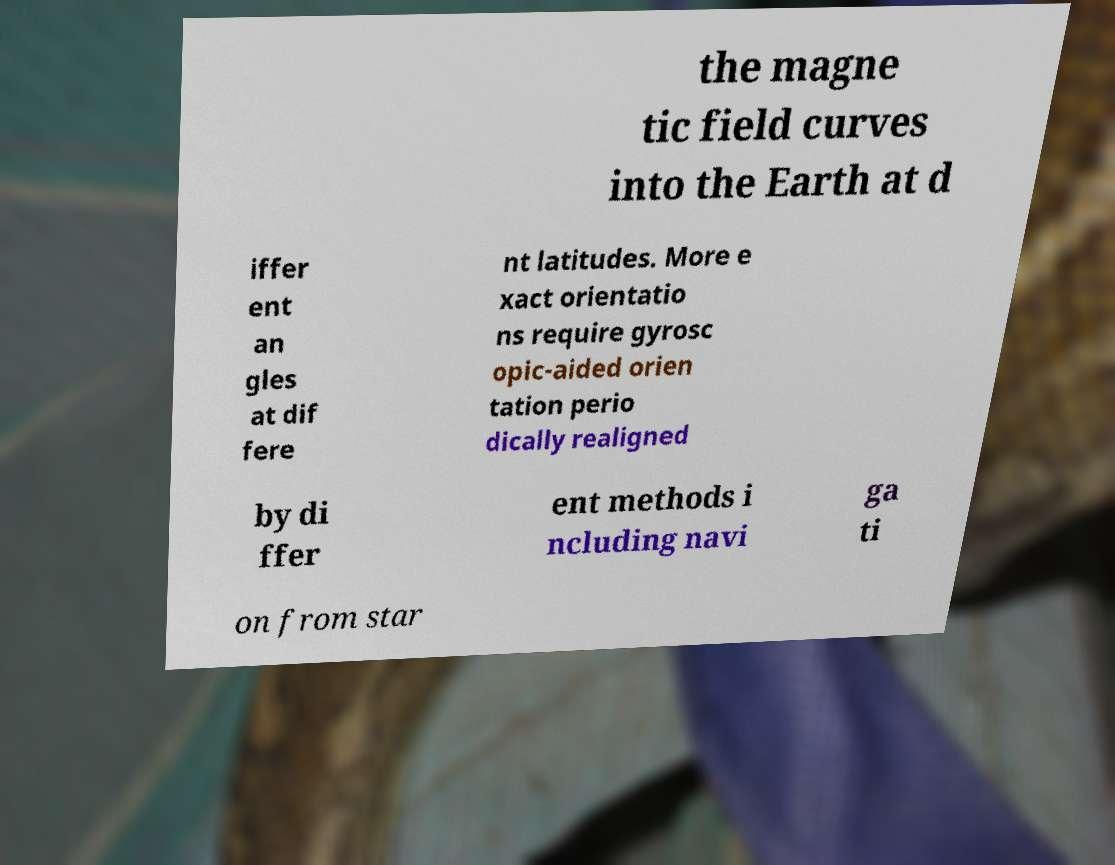Please identify and transcribe the text found in this image. the magne tic field curves into the Earth at d iffer ent an gles at dif fere nt latitudes. More e xact orientatio ns require gyrosc opic-aided orien tation perio dically realigned by di ffer ent methods i ncluding navi ga ti on from star 